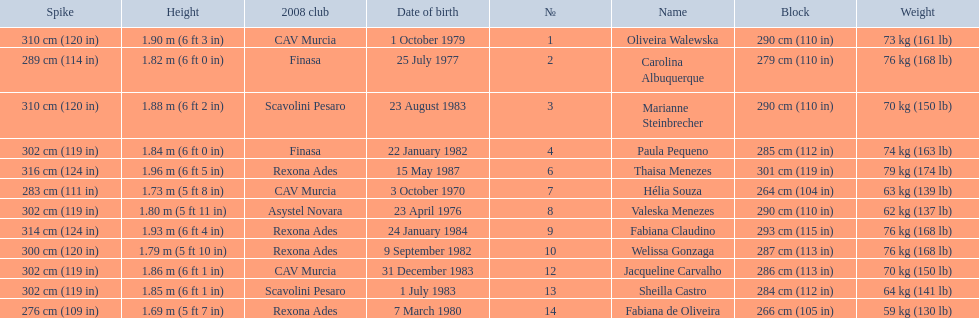What are the names of all the contestants? Oliveira Walewska, Carolina Albuquerque, Marianne Steinbrecher, Paula Pequeno, Thaisa Menezes, Hélia Souza, Valeska Menezes, Fabiana Claudino, Welissa Gonzaga, Jacqueline Carvalho, Sheilla Castro, Fabiana de Oliveira. What are the weight ranges of the contestants? 73 kg (161 lb), 76 kg (168 lb), 70 kg (150 lb), 74 kg (163 lb), 79 kg (174 lb), 63 kg (139 lb), 62 kg (137 lb), 76 kg (168 lb), 76 kg (168 lb), 70 kg (150 lb), 64 kg (141 lb), 59 kg (130 lb). Which player is heaviest. sheilla castro, fabiana de oliveira, or helia souza? Sheilla Castro. 